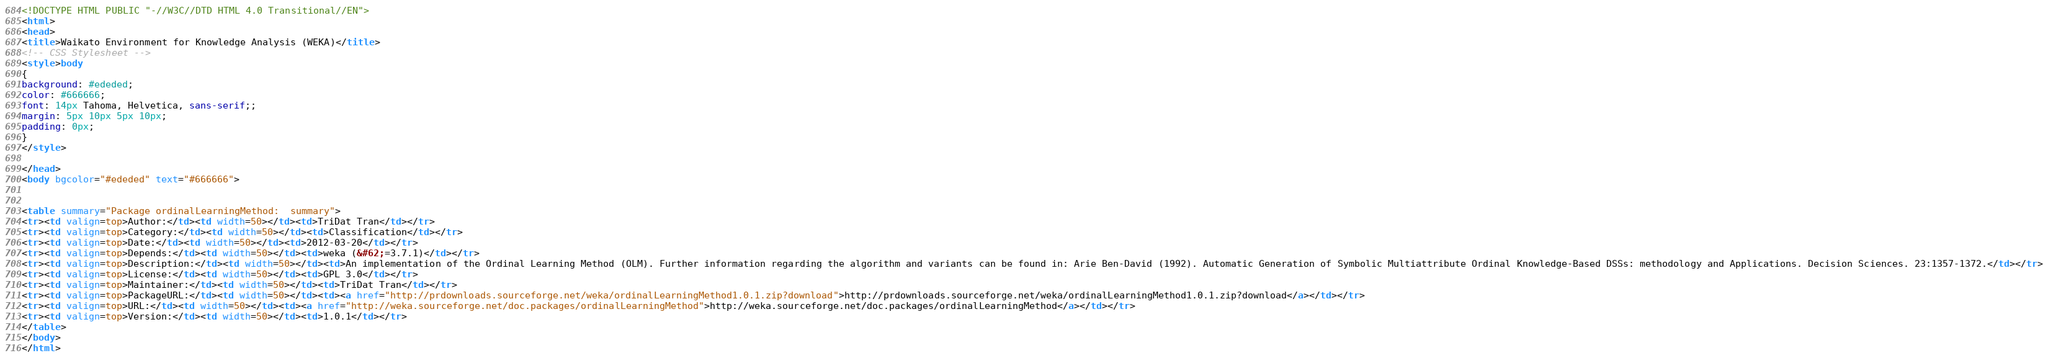Convert code to text. <code><loc_0><loc_0><loc_500><loc_500><_HTML_><!DOCTYPE HTML PUBLIC "-//W3C//DTD HTML 4.0 Transitional//EN">
<html>
<head>
<title>Waikato Environment for Knowledge Analysis (WEKA)</title>
<!-- CSS Stylesheet -->
<style>body
{
background: #ededed;
color: #666666;
font: 14px Tahoma, Helvetica, sans-serif;;
margin: 5px 10px 5px 10px;
padding: 0px;
}
</style>

</head>
<body bgcolor="#ededed" text="#666666">


<table summary="Package ordinalLearningMethod:  summary">
<tr><td valign=top>Author:</td><td width=50></td><td>TriDat Tran</td></tr>
<tr><td valign=top>Category:</td><td width=50></td><td>Classification</td></tr>
<tr><td valign=top>Date:</td><td width=50></td><td>2012-03-20</td></tr>
<tr><td valign=top>Depends:</td><td width=50></td><td>weka (&#62;=3.7.1)</td></tr>
<tr><td valign=top>Description:</td><td width=50></td><td>An implementation of the Ordinal Learning Method (OLM). Further information regarding the algorithm and variants can be found in: Arie Ben-David (1992). Automatic Generation of Symbolic Multiattribute Ordinal Knowledge-Based DSSs: methodology and Applications. Decision Sciences. 23:1357-1372.</td></tr>
<tr><td valign=top>License:</td><td width=50></td><td>GPL 3.0</td></tr>
<tr><td valign=top>Maintainer:</td><td width=50></td><td>TriDat Tran</td></tr>
<tr><td valign=top>PackageURL:</td><td width=50></td><td><a href="http://prdownloads.sourceforge.net/weka/ordinalLearningMethod1.0.1.zip?download">http://prdownloads.sourceforge.net/weka/ordinalLearningMethod1.0.1.zip?download</a></td></tr>
<tr><td valign=top>URL:</td><td width=50></td><td><a href="http://weka.sourceforge.net/doc.packages/ordinalLearningMethod">http://weka.sourceforge.net/doc.packages/ordinalLearningMethod</a></td></tr>
<tr><td valign=top>Version:</td><td width=50></td><td>1.0.1</td></tr>
</table>
</body>
</html>
</code> 